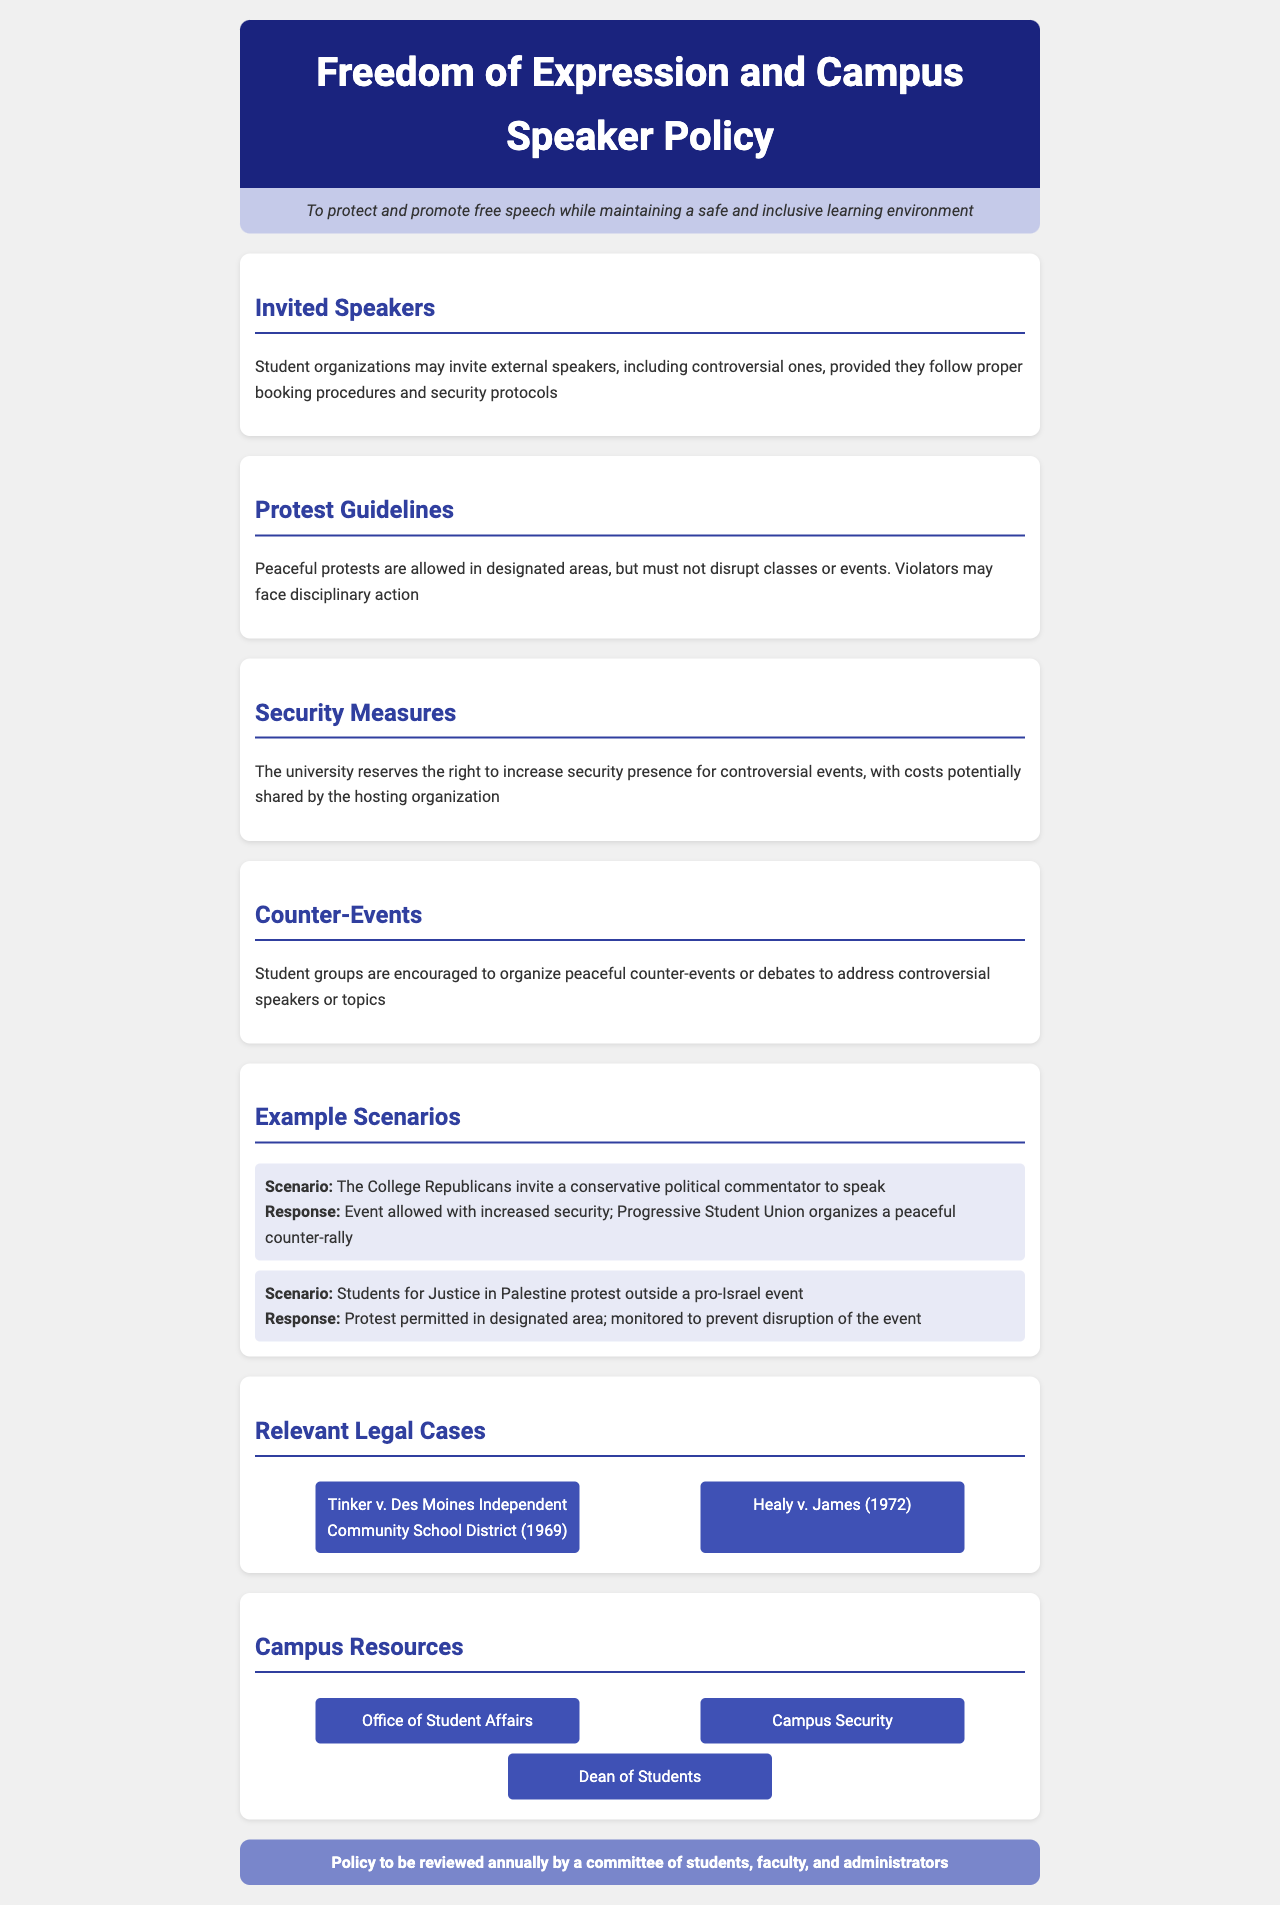What is the purpose of the policy? The purpose is to protect and promote free speech while maintaining a safe and inclusive learning environment.
Answer: To protect and promote free speech while maintaining a safe and inclusive learning environment What must student organizations follow when inviting external speakers? Student organizations must follow proper booking procedures and security protocols.
Answer: Proper booking procedures and security protocols Where are peaceful protests allowed? Peaceful protests are allowed in designated areas.
Answer: Designated areas What may the university increase for controversial events? The university reserves the right to increase security presence.
Answer: Security presence What are students encouraged to organize in response to controversial speakers? Students are encouraged to organize peaceful counter-events or debates.
Answer: Peaceful counter-events or debates Which case involved students wearing armbands? Tinker v. Des Moines Independent Community School District (1969) involved students wearing armbands.
Answer: Tinker v. Des Moines Independent Community School District (1969) How often will the policy be reviewed? The policy will be reviewed annually.
Answer: Annually What type of action may violators of protest guidelines face? Violators may face disciplinary action.
Answer: Disciplinary action Who should be contacted regarding campus resources? Contact should be made with the Office of Student Affairs.
Answer: Office of Student Affairs 